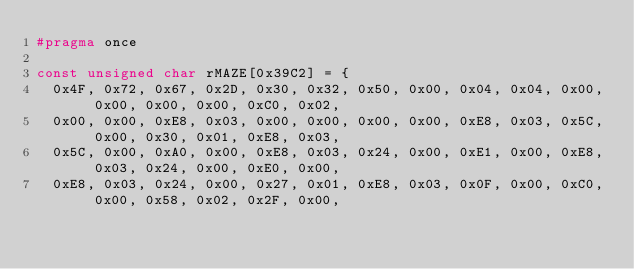Convert code to text. <code><loc_0><loc_0><loc_500><loc_500><_C_>#pragma once

const unsigned char rMAZE[0x39C2] = {
	0x4F, 0x72, 0x67, 0x2D, 0x30, 0x32, 0x50, 0x00, 0x04, 0x04, 0x00, 0x00, 0x00, 0x00, 0xC0, 0x02,
	0x00, 0x00, 0xE8, 0x03, 0x00, 0x00, 0x00, 0x00, 0xE8, 0x03, 0x5C, 0x00, 0x30, 0x01, 0xE8, 0x03,
	0x5C, 0x00, 0xA0, 0x00, 0xE8, 0x03, 0x24, 0x00, 0xE1, 0x00, 0xE8, 0x03, 0x24, 0x00, 0xE0, 0x00,
	0xE8, 0x03, 0x24, 0x00, 0x27, 0x01, 0xE8, 0x03, 0x0F, 0x00, 0xC0, 0x00, 0x58, 0x02, 0x2F, 0x00,</code> 